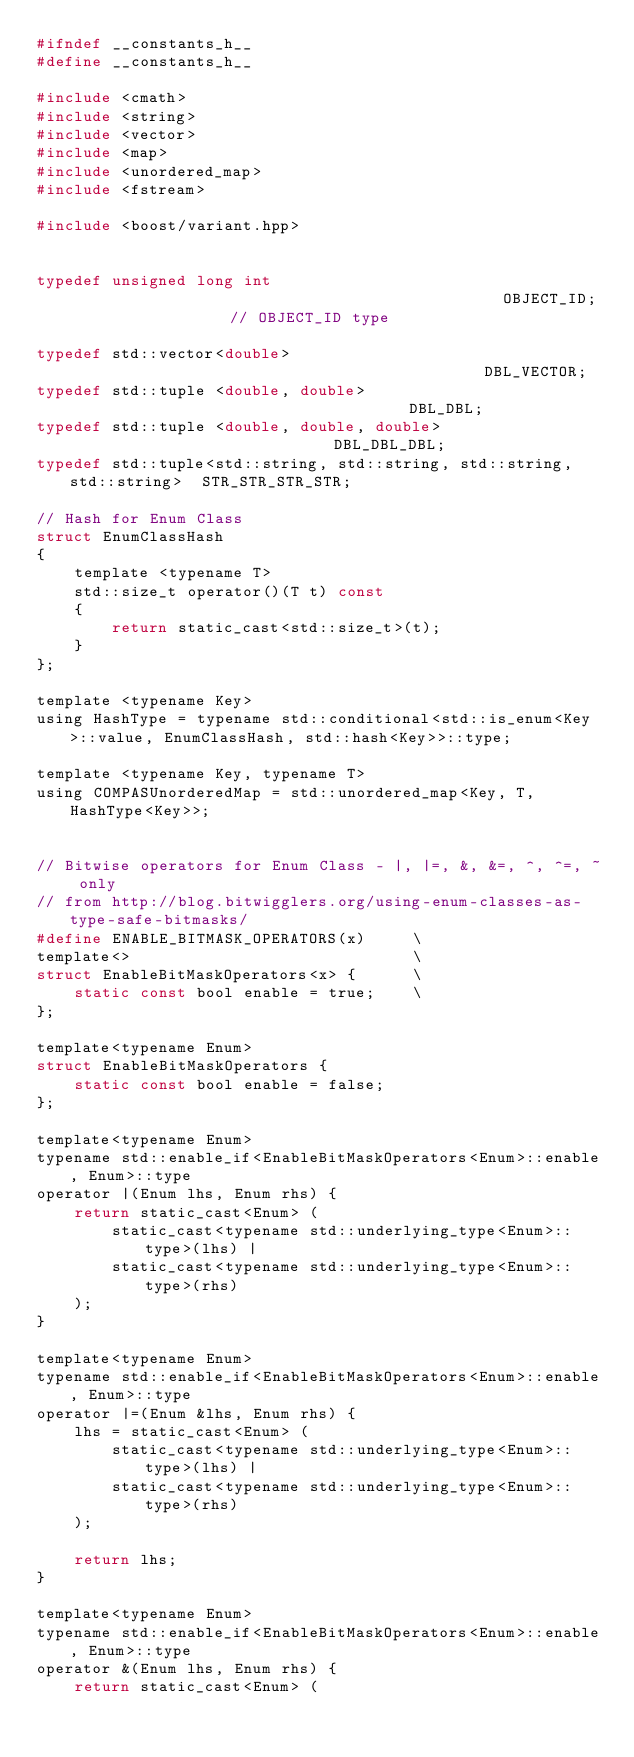<code> <loc_0><loc_0><loc_500><loc_500><_C_>#ifndef __constants_h__
#define __constants_h__

#include <cmath>
#include <string>
#include <vector>
#include <map>
#include <unordered_map>
#include <fstream>

#include <boost/variant.hpp>


typedef unsigned long int                                               OBJECT_ID;                  // OBJECT_ID type

typedef std::vector<double>                                             DBL_VECTOR;
typedef std::tuple <double, double>                                     DBL_DBL;
typedef std::tuple <double, double, double>                             DBL_DBL_DBL;
typedef std::tuple<std::string, std::string, std::string, std::string>  STR_STR_STR_STR;

// Hash for Enum Class
struct EnumClassHash
{
    template <typename T>
    std::size_t operator()(T t) const
    {
        return static_cast<std::size_t>(t);
    }
};

template <typename Key>
using HashType = typename std::conditional<std::is_enum<Key>::value, EnumClassHash, std::hash<Key>>::type;

template <typename Key, typename T>
using COMPASUnorderedMap = std::unordered_map<Key, T, HashType<Key>>;


// Bitwise operators for Enum Class - |, |=, &, &=, ^, ^=, ~ only
// from http://blog.bitwigglers.org/using-enum-classes-as-type-safe-bitmasks/
#define ENABLE_BITMASK_OPERATORS(x)     \
template<>                              \
struct EnableBitMaskOperators<x> {      \
    static const bool enable = true;    \
};

template<typename Enum>  
struct EnableBitMaskOperators {
    static const bool enable = false;
};

template<typename Enum>  
typename std::enable_if<EnableBitMaskOperators<Enum>::enable, Enum>::type  
operator |(Enum lhs, Enum rhs) {
    return static_cast<Enum> (
        static_cast<typename std::underlying_type<Enum>::type>(lhs) |
        static_cast<typename std::underlying_type<Enum>::type>(rhs)
    );
}

template<typename Enum>  
typename std::enable_if<EnableBitMaskOperators<Enum>::enable, Enum>::type  
operator |=(Enum &lhs, Enum rhs) {
    lhs = static_cast<Enum> (
        static_cast<typename std::underlying_type<Enum>::type>(lhs) |
        static_cast<typename std::underlying_type<Enum>::type>(rhs)           
    );

    return lhs;
}

template<typename Enum>  
typename std::enable_if<EnableBitMaskOperators<Enum>::enable, Enum>::type 
operator &(Enum lhs, Enum rhs) {
    return static_cast<Enum> (</code> 